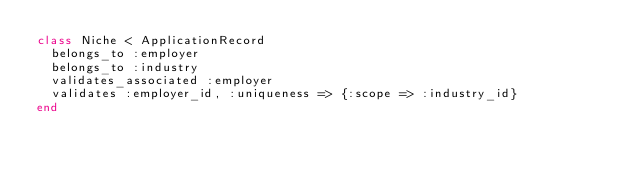Convert code to text. <code><loc_0><loc_0><loc_500><loc_500><_Ruby_>class Niche < ApplicationRecord
  belongs_to :employer
  belongs_to :industry
  validates_associated :employer
  validates :employer_id, :uniqueness => {:scope => :industry_id}
end
</code> 